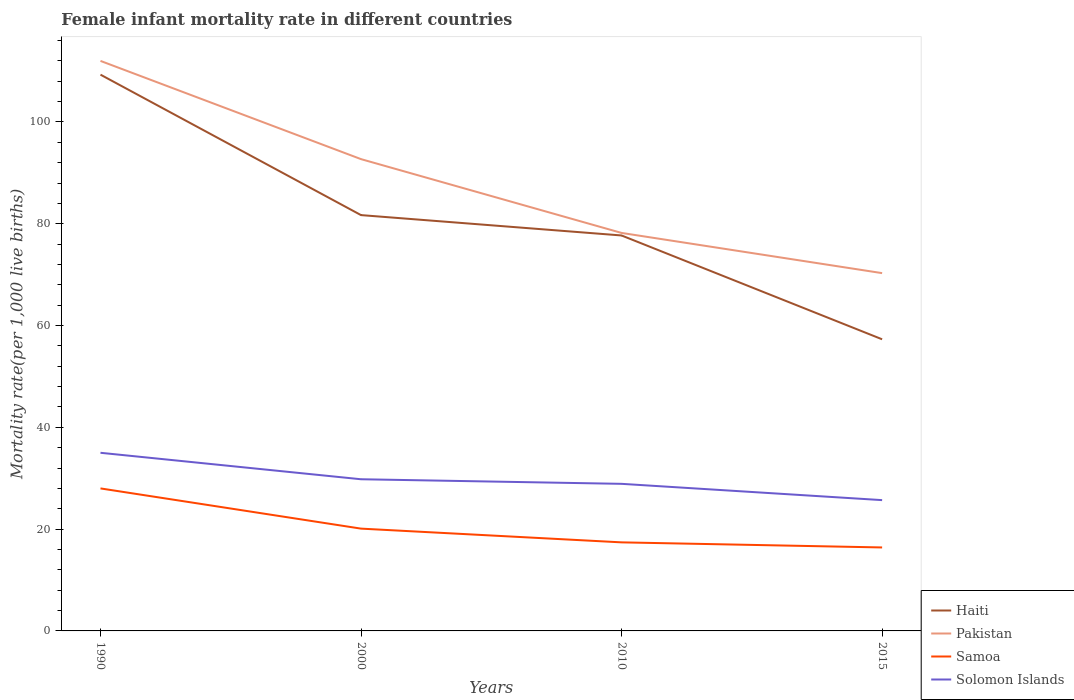Is the number of lines equal to the number of legend labels?
Make the answer very short. Yes. Across all years, what is the maximum female infant mortality rate in Pakistan?
Offer a terse response. 70.3. In which year was the female infant mortality rate in Samoa maximum?
Keep it short and to the point. 2015. What is the total female infant mortality rate in Pakistan in the graph?
Ensure brevity in your answer.  41.7. What is the difference between the highest and the second highest female infant mortality rate in Solomon Islands?
Ensure brevity in your answer.  9.3. Are the values on the major ticks of Y-axis written in scientific E-notation?
Your answer should be very brief. No. Does the graph contain grids?
Give a very brief answer. No. What is the title of the graph?
Make the answer very short. Female infant mortality rate in different countries. Does "South Africa" appear as one of the legend labels in the graph?
Make the answer very short. No. What is the label or title of the X-axis?
Your answer should be very brief. Years. What is the label or title of the Y-axis?
Your response must be concise. Mortality rate(per 1,0 live births). What is the Mortality rate(per 1,000 live births) in Haiti in 1990?
Ensure brevity in your answer.  109.3. What is the Mortality rate(per 1,000 live births) in Pakistan in 1990?
Your response must be concise. 112. What is the Mortality rate(per 1,000 live births) of Haiti in 2000?
Provide a short and direct response. 81.7. What is the Mortality rate(per 1,000 live births) of Pakistan in 2000?
Provide a succinct answer. 92.7. What is the Mortality rate(per 1,000 live births) in Samoa in 2000?
Offer a terse response. 20.1. What is the Mortality rate(per 1,000 live births) in Solomon Islands in 2000?
Ensure brevity in your answer.  29.8. What is the Mortality rate(per 1,000 live births) of Haiti in 2010?
Your answer should be very brief. 77.7. What is the Mortality rate(per 1,000 live births) of Pakistan in 2010?
Give a very brief answer. 78.2. What is the Mortality rate(per 1,000 live births) in Samoa in 2010?
Give a very brief answer. 17.4. What is the Mortality rate(per 1,000 live births) in Solomon Islands in 2010?
Your answer should be very brief. 28.9. What is the Mortality rate(per 1,000 live births) in Haiti in 2015?
Keep it short and to the point. 57.3. What is the Mortality rate(per 1,000 live births) of Pakistan in 2015?
Provide a succinct answer. 70.3. What is the Mortality rate(per 1,000 live births) of Samoa in 2015?
Offer a terse response. 16.4. What is the Mortality rate(per 1,000 live births) of Solomon Islands in 2015?
Offer a terse response. 25.7. Across all years, what is the maximum Mortality rate(per 1,000 live births) in Haiti?
Your response must be concise. 109.3. Across all years, what is the maximum Mortality rate(per 1,000 live births) in Pakistan?
Ensure brevity in your answer.  112. Across all years, what is the maximum Mortality rate(per 1,000 live births) of Samoa?
Your answer should be very brief. 28. Across all years, what is the maximum Mortality rate(per 1,000 live births) in Solomon Islands?
Your response must be concise. 35. Across all years, what is the minimum Mortality rate(per 1,000 live births) in Haiti?
Your response must be concise. 57.3. Across all years, what is the minimum Mortality rate(per 1,000 live births) in Pakistan?
Provide a succinct answer. 70.3. Across all years, what is the minimum Mortality rate(per 1,000 live births) of Samoa?
Keep it short and to the point. 16.4. Across all years, what is the minimum Mortality rate(per 1,000 live births) in Solomon Islands?
Your answer should be very brief. 25.7. What is the total Mortality rate(per 1,000 live births) of Haiti in the graph?
Offer a terse response. 326. What is the total Mortality rate(per 1,000 live births) of Pakistan in the graph?
Offer a very short reply. 353.2. What is the total Mortality rate(per 1,000 live births) of Samoa in the graph?
Your answer should be compact. 81.9. What is the total Mortality rate(per 1,000 live births) in Solomon Islands in the graph?
Provide a short and direct response. 119.4. What is the difference between the Mortality rate(per 1,000 live births) in Haiti in 1990 and that in 2000?
Your answer should be very brief. 27.6. What is the difference between the Mortality rate(per 1,000 live births) of Pakistan in 1990 and that in 2000?
Your answer should be compact. 19.3. What is the difference between the Mortality rate(per 1,000 live births) in Samoa in 1990 and that in 2000?
Your answer should be compact. 7.9. What is the difference between the Mortality rate(per 1,000 live births) of Haiti in 1990 and that in 2010?
Make the answer very short. 31.6. What is the difference between the Mortality rate(per 1,000 live births) in Pakistan in 1990 and that in 2010?
Give a very brief answer. 33.8. What is the difference between the Mortality rate(per 1,000 live births) in Solomon Islands in 1990 and that in 2010?
Provide a short and direct response. 6.1. What is the difference between the Mortality rate(per 1,000 live births) in Pakistan in 1990 and that in 2015?
Provide a succinct answer. 41.7. What is the difference between the Mortality rate(per 1,000 live births) of Samoa in 1990 and that in 2015?
Offer a very short reply. 11.6. What is the difference between the Mortality rate(per 1,000 live births) in Solomon Islands in 1990 and that in 2015?
Provide a short and direct response. 9.3. What is the difference between the Mortality rate(per 1,000 live births) of Haiti in 2000 and that in 2010?
Keep it short and to the point. 4. What is the difference between the Mortality rate(per 1,000 live births) in Pakistan in 2000 and that in 2010?
Offer a terse response. 14.5. What is the difference between the Mortality rate(per 1,000 live births) in Solomon Islands in 2000 and that in 2010?
Your answer should be compact. 0.9. What is the difference between the Mortality rate(per 1,000 live births) of Haiti in 2000 and that in 2015?
Your answer should be compact. 24.4. What is the difference between the Mortality rate(per 1,000 live births) in Pakistan in 2000 and that in 2015?
Your response must be concise. 22.4. What is the difference between the Mortality rate(per 1,000 live births) in Solomon Islands in 2000 and that in 2015?
Ensure brevity in your answer.  4.1. What is the difference between the Mortality rate(per 1,000 live births) in Haiti in 2010 and that in 2015?
Your answer should be very brief. 20.4. What is the difference between the Mortality rate(per 1,000 live births) of Samoa in 2010 and that in 2015?
Offer a terse response. 1. What is the difference between the Mortality rate(per 1,000 live births) of Solomon Islands in 2010 and that in 2015?
Give a very brief answer. 3.2. What is the difference between the Mortality rate(per 1,000 live births) of Haiti in 1990 and the Mortality rate(per 1,000 live births) of Pakistan in 2000?
Offer a very short reply. 16.6. What is the difference between the Mortality rate(per 1,000 live births) of Haiti in 1990 and the Mortality rate(per 1,000 live births) of Samoa in 2000?
Give a very brief answer. 89.2. What is the difference between the Mortality rate(per 1,000 live births) in Haiti in 1990 and the Mortality rate(per 1,000 live births) in Solomon Islands in 2000?
Give a very brief answer. 79.5. What is the difference between the Mortality rate(per 1,000 live births) of Pakistan in 1990 and the Mortality rate(per 1,000 live births) of Samoa in 2000?
Keep it short and to the point. 91.9. What is the difference between the Mortality rate(per 1,000 live births) of Pakistan in 1990 and the Mortality rate(per 1,000 live births) of Solomon Islands in 2000?
Ensure brevity in your answer.  82.2. What is the difference between the Mortality rate(per 1,000 live births) of Samoa in 1990 and the Mortality rate(per 1,000 live births) of Solomon Islands in 2000?
Provide a short and direct response. -1.8. What is the difference between the Mortality rate(per 1,000 live births) of Haiti in 1990 and the Mortality rate(per 1,000 live births) of Pakistan in 2010?
Make the answer very short. 31.1. What is the difference between the Mortality rate(per 1,000 live births) of Haiti in 1990 and the Mortality rate(per 1,000 live births) of Samoa in 2010?
Ensure brevity in your answer.  91.9. What is the difference between the Mortality rate(per 1,000 live births) in Haiti in 1990 and the Mortality rate(per 1,000 live births) in Solomon Islands in 2010?
Your answer should be very brief. 80.4. What is the difference between the Mortality rate(per 1,000 live births) in Pakistan in 1990 and the Mortality rate(per 1,000 live births) in Samoa in 2010?
Make the answer very short. 94.6. What is the difference between the Mortality rate(per 1,000 live births) of Pakistan in 1990 and the Mortality rate(per 1,000 live births) of Solomon Islands in 2010?
Your answer should be very brief. 83.1. What is the difference between the Mortality rate(per 1,000 live births) in Samoa in 1990 and the Mortality rate(per 1,000 live births) in Solomon Islands in 2010?
Your response must be concise. -0.9. What is the difference between the Mortality rate(per 1,000 live births) in Haiti in 1990 and the Mortality rate(per 1,000 live births) in Samoa in 2015?
Your answer should be very brief. 92.9. What is the difference between the Mortality rate(per 1,000 live births) of Haiti in 1990 and the Mortality rate(per 1,000 live births) of Solomon Islands in 2015?
Ensure brevity in your answer.  83.6. What is the difference between the Mortality rate(per 1,000 live births) in Pakistan in 1990 and the Mortality rate(per 1,000 live births) in Samoa in 2015?
Keep it short and to the point. 95.6. What is the difference between the Mortality rate(per 1,000 live births) in Pakistan in 1990 and the Mortality rate(per 1,000 live births) in Solomon Islands in 2015?
Make the answer very short. 86.3. What is the difference between the Mortality rate(per 1,000 live births) in Haiti in 2000 and the Mortality rate(per 1,000 live births) in Pakistan in 2010?
Ensure brevity in your answer.  3.5. What is the difference between the Mortality rate(per 1,000 live births) of Haiti in 2000 and the Mortality rate(per 1,000 live births) of Samoa in 2010?
Provide a short and direct response. 64.3. What is the difference between the Mortality rate(per 1,000 live births) of Haiti in 2000 and the Mortality rate(per 1,000 live births) of Solomon Islands in 2010?
Your answer should be compact. 52.8. What is the difference between the Mortality rate(per 1,000 live births) of Pakistan in 2000 and the Mortality rate(per 1,000 live births) of Samoa in 2010?
Provide a succinct answer. 75.3. What is the difference between the Mortality rate(per 1,000 live births) of Pakistan in 2000 and the Mortality rate(per 1,000 live births) of Solomon Islands in 2010?
Your response must be concise. 63.8. What is the difference between the Mortality rate(per 1,000 live births) in Haiti in 2000 and the Mortality rate(per 1,000 live births) in Samoa in 2015?
Your answer should be compact. 65.3. What is the difference between the Mortality rate(per 1,000 live births) in Pakistan in 2000 and the Mortality rate(per 1,000 live births) in Samoa in 2015?
Offer a very short reply. 76.3. What is the difference between the Mortality rate(per 1,000 live births) in Samoa in 2000 and the Mortality rate(per 1,000 live births) in Solomon Islands in 2015?
Provide a succinct answer. -5.6. What is the difference between the Mortality rate(per 1,000 live births) in Haiti in 2010 and the Mortality rate(per 1,000 live births) in Samoa in 2015?
Give a very brief answer. 61.3. What is the difference between the Mortality rate(per 1,000 live births) of Haiti in 2010 and the Mortality rate(per 1,000 live births) of Solomon Islands in 2015?
Provide a succinct answer. 52. What is the difference between the Mortality rate(per 1,000 live births) in Pakistan in 2010 and the Mortality rate(per 1,000 live births) in Samoa in 2015?
Give a very brief answer. 61.8. What is the difference between the Mortality rate(per 1,000 live births) of Pakistan in 2010 and the Mortality rate(per 1,000 live births) of Solomon Islands in 2015?
Provide a succinct answer. 52.5. What is the difference between the Mortality rate(per 1,000 live births) of Samoa in 2010 and the Mortality rate(per 1,000 live births) of Solomon Islands in 2015?
Give a very brief answer. -8.3. What is the average Mortality rate(per 1,000 live births) of Haiti per year?
Make the answer very short. 81.5. What is the average Mortality rate(per 1,000 live births) in Pakistan per year?
Offer a very short reply. 88.3. What is the average Mortality rate(per 1,000 live births) of Samoa per year?
Provide a succinct answer. 20.48. What is the average Mortality rate(per 1,000 live births) in Solomon Islands per year?
Give a very brief answer. 29.85. In the year 1990, what is the difference between the Mortality rate(per 1,000 live births) in Haiti and Mortality rate(per 1,000 live births) in Pakistan?
Your answer should be very brief. -2.7. In the year 1990, what is the difference between the Mortality rate(per 1,000 live births) of Haiti and Mortality rate(per 1,000 live births) of Samoa?
Offer a terse response. 81.3. In the year 1990, what is the difference between the Mortality rate(per 1,000 live births) in Haiti and Mortality rate(per 1,000 live births) in Solomon Islands?
Make the answer very short. 74.3. In the year 1990, what is the difference between the Mortality rate(per 1,000 live births) in Samoa and Mortality rate(per 1,000 live births) in Solomon Islands?
Provide a succinct answer. -7. In the year 2000, what is the difference between the Mortality rate(per 1,000 live births) of Haiti and Mortality rate(per 1,000 live births) of Pakistan?
Provide a succinct answer. -11. In the year 2000, what is the difference between the Mortality rate(per 1,000 live births) in Haiti and Mortality rate(per 1,000 live births) in Samoa?
Provide a short and direct response. 61.6. In the year 2000, what is the difference between the Mortality rate(per 1,000 live births) in Haiti and Mortality rate(per 1,000 live births) in Solomon Islands?
Offer a terse response. 51.9. In the year 2000, what is the difference between the Mortality rate(per 1,000 live births) of Pakistan and Mortality rate(per 1,000 live births) of Samoa?
Make the answer very short. 72.6. In the year 2000, what is the difference between the Mortality rate(per 1,000 live births) in Pakistan and Mortality rate(per 1,000 live births) in Solomon Islands?
Your answer should be compact. 62.9. In the year 2010, what is the difference between the Mortality rate(per 1,000 live births) in Haiti and Mortality rate(per 1,000 live births) in Samoa?
Make the answer very short. 60.3. In the year 2010, what is the difference between the Mortality rate(per 1,000 live births) of Haiti and Mortality rate(per 1,000 live births) of Solomon Islands?
Your response must be concise. 48.8. In the year 2010, what is the difference between the Mortality rate(per 1,000 live births) in Pakistan and Mortality rate(per 1,000 live births) in Samoa?
Keep it short and to the point. 60.8. In the year 2010, what is the difference between the Mortality rate(per 1,000 live births) of Pakistan and Mortality rate(per 1,000 live births) of Solomon Islands?
Provide a succinct answer. 49.3. In the year 2010, what is the difference between the Mortality rate(per 1,000 live births) in Samoa and Mortality rate(per 1,000 live births) in Solomon Islands?
Provide a short and direct response. -11.5. In the year 2015, what is the difference between the Mortality rate(per 1,000 live births) in Haiti and Mortality rate(per 1,000 live births) in Pakistan?
Your answer should be compact. -13. In the year 2015, what is the difference between the Mortality rate(per 1,000 live births) in Haiti and Mortality rate(per 1,000 live births) in Samoa?
Your answer should be very brief. 40.9. In the year 2015, what is the difference between the Mortality rate(per 1,000 live births) in Haiti and Mortality rate(per 1,000 live births) in Solomon Islands?
Make the answer very short. 31.6. In the year 2015, what is the difference between the Mortality rate(per 1,000 live births) of Pakistan and Mortality rate(per 1,000 live births) of Samoa?
Your answer should be very brief. 53.9. In the year 2015, what is the difference between the Mortality rate(per 1,000 live births) of Pakistan and Mortality rate(per 1,000 live births) of Solomon Islands?
Provide a short and direct response. 44.6. In the year 2015, what is the difference between the Mortality rate(per 1,000 live births) in Samoa and Mortality rate(per 1,000 live births) in Solomon Islands?
Offer a very short reply. -9.3. What is the ratio of the Mortality rate(per 1,000 live births) in Haiti in 1990 to that in 2000?
Offer a very short reply. 1.34. What is the ratio of the Mortality rate(per 1,000 live births) of Pakistan in 1990 to that in 2000?
Your response must be concise. 1.21. What is the ratio of the Mortality rate(per 1,000 live births) in Samoa in 1990 to that in 2000?
Provide a short and direct response. 1.39. What is the ratio of the Mortality rate(per 1,000 live births) of Solomon Islands in 1990 to that in 2000?
Provide a short and direct response. 1.17. What is the ratio of the Mortality rate(per 1,000 live births) in Haiti in 1990 to that in 2010?
Keep it short and to the point. 1.41. What is the ratio of the Mortality rate(per 1,000 live births) in Pakistan in 1990 to that in 2010?
Your response must be concise. 1.43. What is the ratio of the Mortality rate(per 1,000 live births) of Samoa in 1990 to that in 2010?
Keep it short and to the point. 1.61. What is the ratio of the Mortality rate(per 1,000 live births) of Solomon Islands in 1990 to that in 2010?
Provide a short and direct response. 1.21. What is the ratio of the Mortality rate(per 1,000 live births) in Haiti in 1990 to that in 2015?
Provide a succinct answer. 1.91. What is the ratio of the Mortality rate(per 1,000 live births) in Pakistan in 1990 to that in 2015?
Provide a succinct answer. 1.59. What is the ratio of the Mortality rate(per 1,000 live births) in Samoa in 1990 to that in 2015?
Make the answer very short. 1.71. What is the ratio of the Mortality rate(per 1,000 live births) in Solomon Islands in 1990 to that in 2015?
Offer a terse response. 1.36. What is the ratio of the Mortality rate(per 1,000 live births) of Haiti in 2000 to that in 2010?
Make the answer very short. 1.05. What is the ratio of the Mortality rate(per 1,000 live births) in Pakistan in 2000 to that in 2010?
Provide a succinct answer. 1.19. What is the ratio of the Mortality rate(per 1,000 live births) in Samoa in 2000 to that in 2010?
Make the answer very short. 1.16. What is the ratio of the Mortality rate(per 1,000 live births) of Solomon Islands in 2000 to that in 2010?
Give a very brief answer. 1.03. What is the ratio of the Mortality rate(per 1,000 live births) of Haiti in 2000 to that in 2015?
Give a very brief answer. 1.43. What is the ratio of the Mortality rate(per 1,000 live births) of Pakistan in 2000 to that in 2015?
Provide a succinct answer. 1.32. What is the ratio of the Mortality rate(per 1,000 live births) in Samoa in 2000 to that in 2015?
Your answer should be very brief. 1.23. What is the ratio of the Mortality rate(per 1,000 live births) of Solomon Islands in 2000 to that in 2015?
Give a very brief answer. 1.16. What is the ratio of the Mortality rate(per 1,000 live births) in Haiti in 2010 to that in 2015?
Provide a succinct answer. 1.36. What is the ratio of the Mortality rate(per 1,000 live births) in Pakistan in 2010 to that in 2015?
Your response must be concise. 1.11. What is the ratio of the Mortality rate(per 1,000 live births) in Samoa in 2010 to that in 2015?
Provide a succinct answer. 1.06. What is the ratio of the Mortality rate(per 1,000 live births) in Solomon Islands in 2010 to that in 2015?
Provide a short and direct response. 1.12. What is the difference between the highest and the second highest Mortality rate(per 1,000 live births) of Haiti?
Provide a succinct answer. 27.6. What is the difference between the highest and the second highest Mortality rate(per 1,000 live births) of Pakistan?
Your answer should be compact. 19.3. What is the difference between the highest and the second highest Mortality rate(per 1,000 live births) in Solomon Islands?
Keep it short and to the point. 5.2. What is the difference between the highest and the lowest Mortality rate(per 1,000 live births) in Pakistan?
Your answer should be very brief. 41.7. 